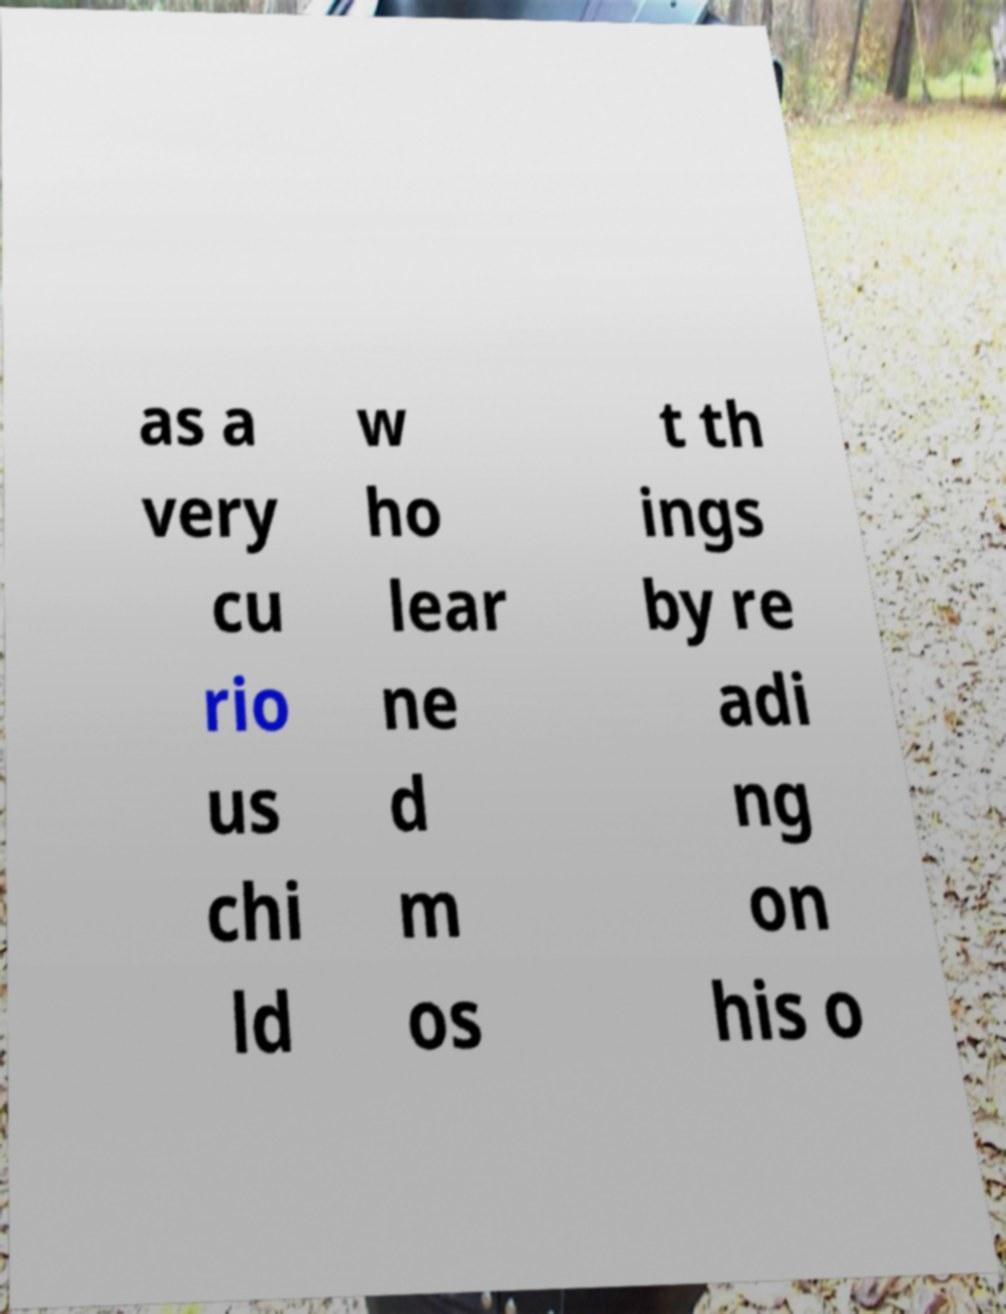Please read and relay the text visible in this image. What does it say? as a very cu rio us chi ld w ho lear ne d m os t th ings by re adi ng on his o 